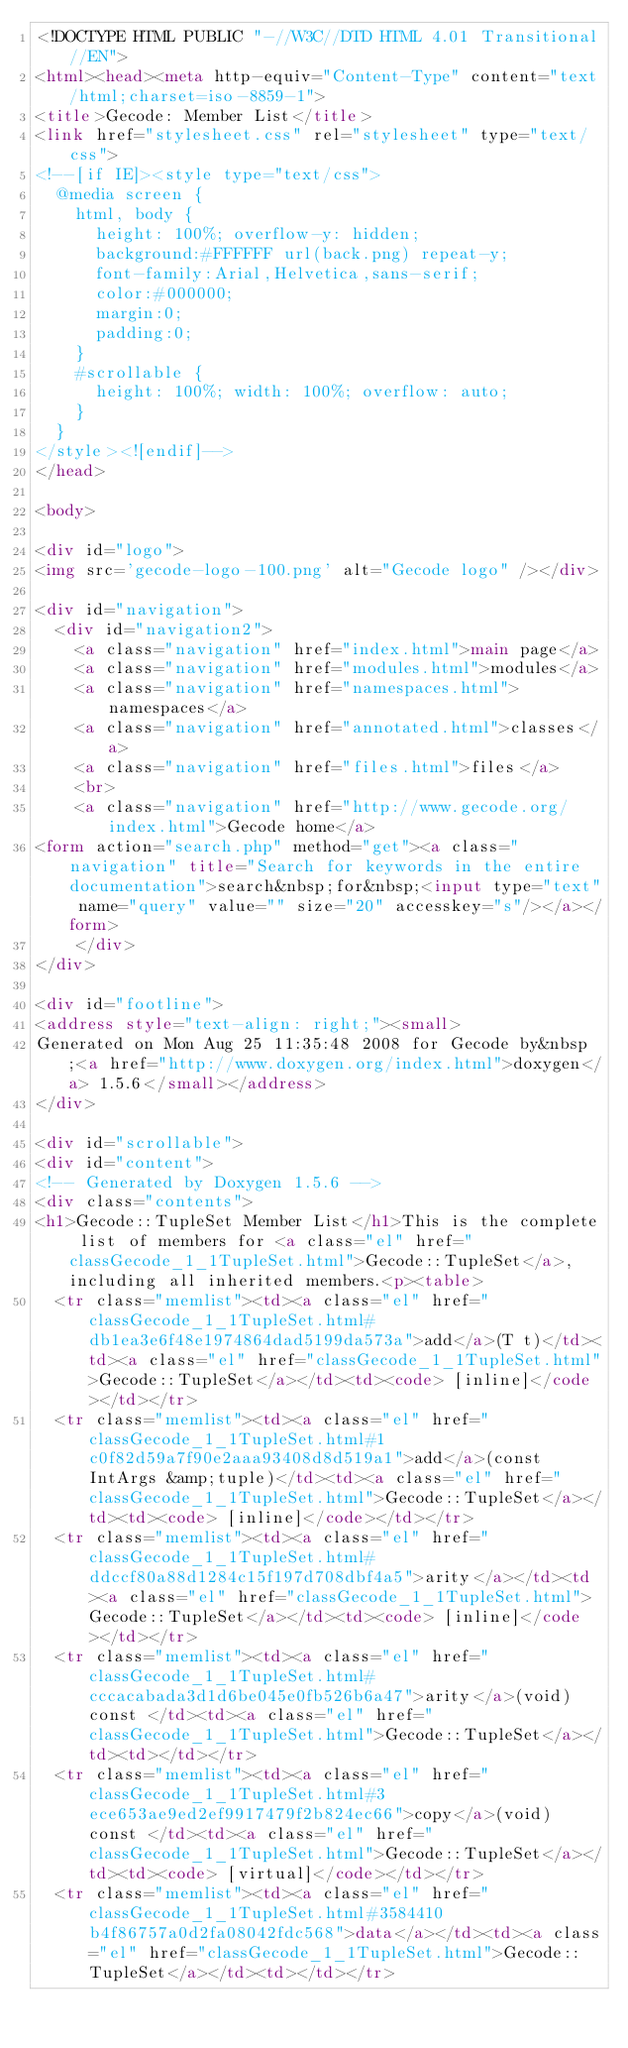Convert code to text. <code><loc_0><loc_0><loc_500><loc_500><_HTML_><!DOCTYPE HTML PUBLIC "-//W3C//DTD HTML 4.01 Transitional//EN">
<html><head><meta http-equiv="Content-Type" content="text/html;charset=iso-8859-1">
<title>Gecode: Member List</title>
<link href="stylesheet.css" rel="stylesheet" type="text/css">
<!--[if IE]><style type="text/css">
  @media screen {
    html, body {
      height: 100%; overflow-y: hidden;
      background:#FFFFFF url(back.png) repeat-y;
      font-family:Arial,Helvetica,sans-serif;
      color:#000000;
      margin:0;
      padding:0;
    }
    #scrollable {
      height: 100%; width: 100%; overflow: auto;
    }
  }
</style><![endif]-->
</head>

<body>

<div id="logo">
<img src='gecode-logo-100.png' alt="Gecode logo" /></div>

<div id="navigation">
  <div id="navigation2">
    <a class="navigation" href="index.html">main page</a>
    <a class="navigation" href="modules.html">modules</a>
    <a class="navigation" href="namespaces.html">namespaces</a>
    <a class="navigation" href="annotated.html">classes</a>
    <a class="navigation" href="files.html">files</a>
    <br>
    <a class="navigation" href="http://www.gecode.org/index.html">Gecode home</a>
<form action="search.php" method="get"><a class="navigation" title="Search for keywords in the entire documentation">search&nbsp;for&nbsp;<input type="text" name="query" value="" size="20" accesskey="s"/></a></form>
    </div>
</div>

<div id="footline">
<address style="text-align: right;"><small>
Generated on Mon Aug 25 11:35:48 2008 for Gecode by&nbsp;<a href="http://www.doxygen.org/index.html">doxygen</a> 1.5.6</small></address>
</div>

<div id="scrollable">
<div id="content">
<!-- Generated by Doxygen 1.5.6 -->
<div class="contents">
<h1>Gecode::TupleSet Member List</h1>This is the complete list of members for <a class="el" href="classGecode_1_1TupleSet.html">Gecode::TupleSet</a>, including all inherited members.<p><table>
  <tr class="memlist"><td><a class="el" href="classGecode_1_1TupleSet.html#db1ea3e6f48e1974864dad5199da573a">add</a>(T t)</td><td><a class="el" href="classGecode_1_1TupleSet.html">Gecode::TupleSet</a></td><td><code> [inline]</code></td></tr>
  <tr class="memlist"><td><a class="el" href="classGecode_1_1TupleSet.html#1c0f82d59a7f90e2aaa93408d8d519a1">add</a>(const IntArgs &amp;tuple)</td><td><a class="el" href="classGecode_1_1TupleSet.html">Gecode::TupleSet</a></td><td><code> [inline]</code></td></tr>
  <tr class="memlist"><td><a class="el" href="classGecode_1_1TupleSet.html#ddccf80a88d1284c15f197d708dbf4a5">arity</a></td><td><a class="el" href="classGecode_1_1TupleSet.html">Gecode::TupleSet</a></td><td><code> [inline]</code></td></tr>
  <tr class="memlist"><td><a class="el" href="classGecode_1_1TupleSet.html#cccacabada3d1d6be045e0fb526b6a47">arity</a>(void) const </td><td><a class="el" href="classGecode_1_1TupleSet.html">Gecode::TupleSet</a></td><td></td></tr>
  <tr class="memlist"><td><a class="el" href="classGecode_1_1TupleSet.html#3ece653ae9ed2ef9917479f2b824ec66">copy</a>(void) const </td><td><a class="el" href="classGecode_1_1TupleSet.html">Gecode::TupleSet</a></td><td><code> [virtual]</code></td></tr>
  <tr class="memlist"><td><a class="el" href="classGecode_1_1TupleSet.html#3584410b4f86757a0d2fa08042fdc568">data</a></td><td><a class="el" href="classGecode_1_1TupleSet.html">Gecode::TupleSet</a></td><td></td></tr></code> 